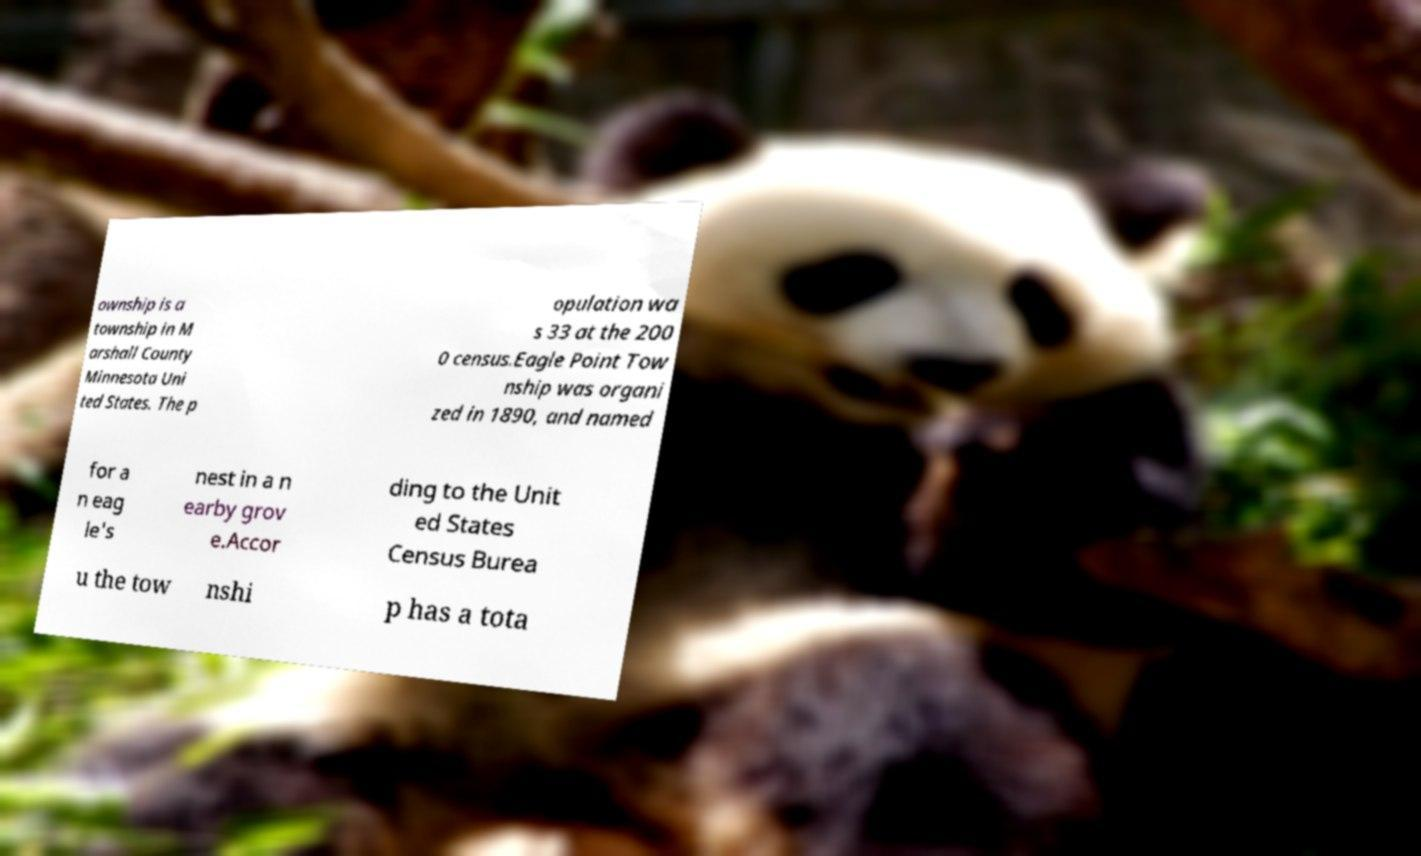Can you accurately transcribe the text from the provided image for me? ownship is a township in M arshall County Minnesota Uni ted States. The p opulation wa s 33 at the 200 0 census.Eagle Point Tow nship was organi zed in 1890, and named for a n eag le's nest in a n earby grov e.Accor ding to the Unit ed States Census Burea u the tow nshi p has a tota 